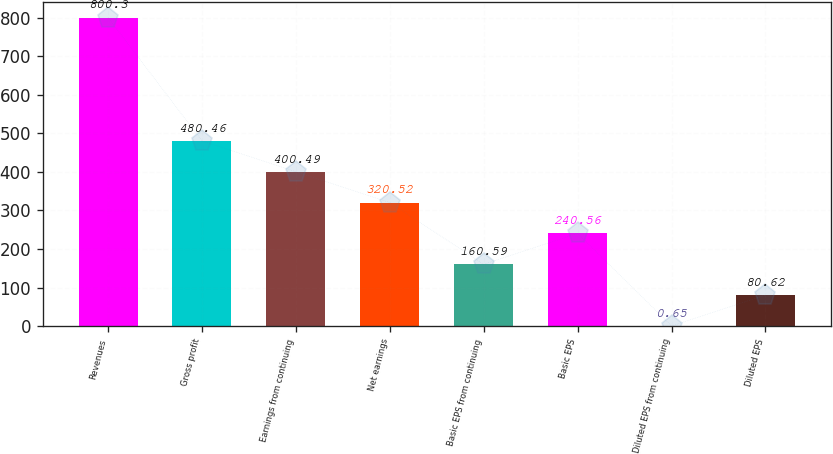Convert chart to OTSL. <chart><loc_0><loc_0><loc_500><loc_500><bar_chart><fcel>Revenues<fcel>Gross profit<fcel>Earnings from continuing<fcel>Net earnings<fcel>Basic EPS from continuing<fcel>Basic EPS<fcel>Diluted EPS from continuing<fcel>Diluted EPS<nl><fcel>800.3<fcel>480.46<fcel>400.49<fcel>320.52<fcel>160.59<fcel>240.56<fcel>0.65<fcel>80.62<nl></chart> 